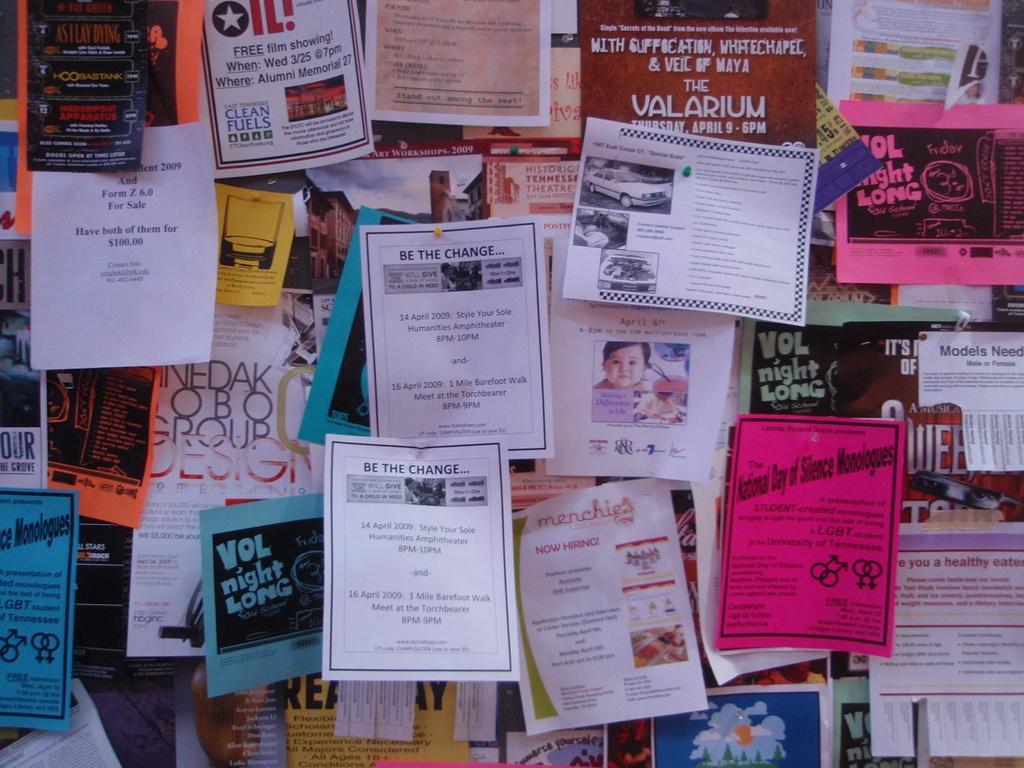In one or two sentences, can you explain what this image depicts? In this picture there are different types of pamphlets in the image. 